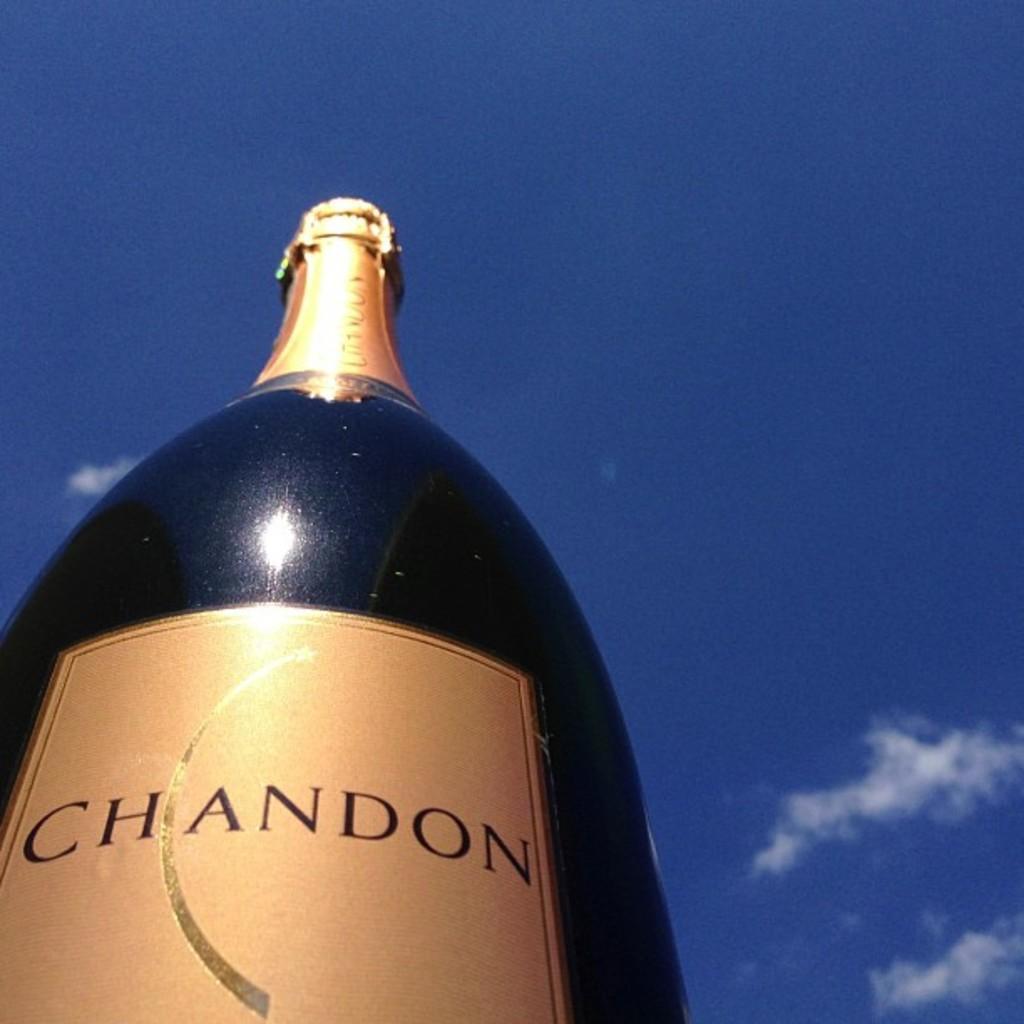How would you summarize this image in a sentence or two? In the bottom left corner of the image we can see a bottle. At the top of the image there are some clouds in the sky. 